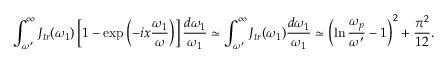<formula> <loc_0><loc_0><loc_500><loc_500>\int _ { \omega ^ { \prime } } ^ { \infty } J _ { t r } ( \omega _ { 1 } ) \left [ 1 - \exp \left ( - i x \frac { \omega _ { 1 } } { \omega } \right ) \right ] \frac { d \omega _ { 1 } } { \omega _ { 1 } } \simeq \int _ { \omega ^ { \prime } } ^ { \infty } J _ { t r } ( \omega _ { 1 } ) \frac { d \omega _ { 1 } } { \omega _ { 1 } } \simeq \left ( \ln \frac { \omega _ { p } } { \omega ^ { \prime } } - 1 \right ) ^ { 2 } + \frac { \pi ^ { 2 } } { 1 2 } .</formula> 